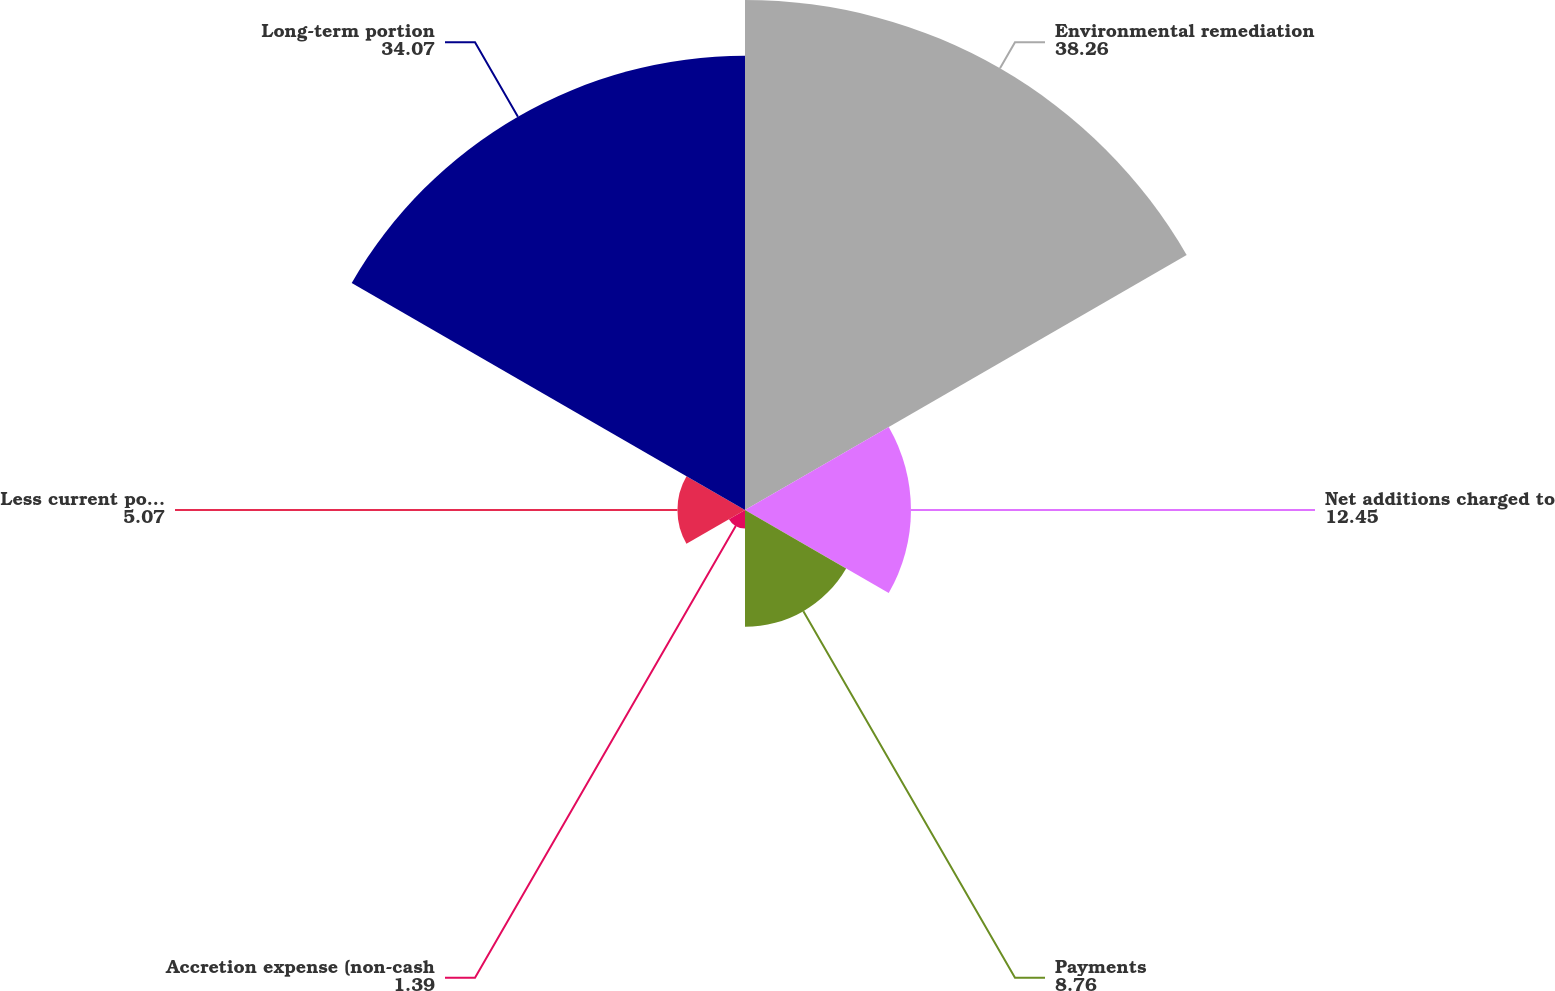Convert chart to OTSL. <chart><loc_0><loc_0><loc_500><loc_500><pie_chart><fcel>Environmental remediation<fcel>Net additions charged to<fcel>Payments<fcel>Accretion expense (non-cash<fcel>Less current portion<fcel>Long-term portion<nl><fcel>38.26%<fcel>12.45%<fcel>8.76%<fcel>1.39%<fcel>5.07%<fcel>34.07%<nl></chart> 